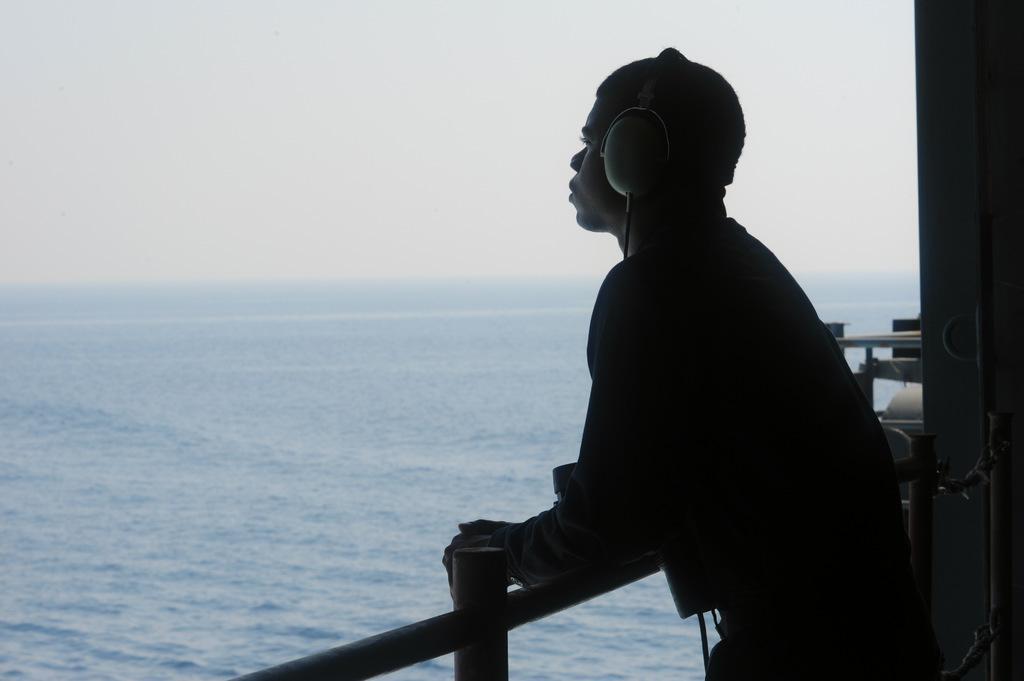Could you give a brief overview of what you see in this image? There is a man wearing headsets is standing near to a railing. On the right side there is a wall. In the back there is water and sky. 